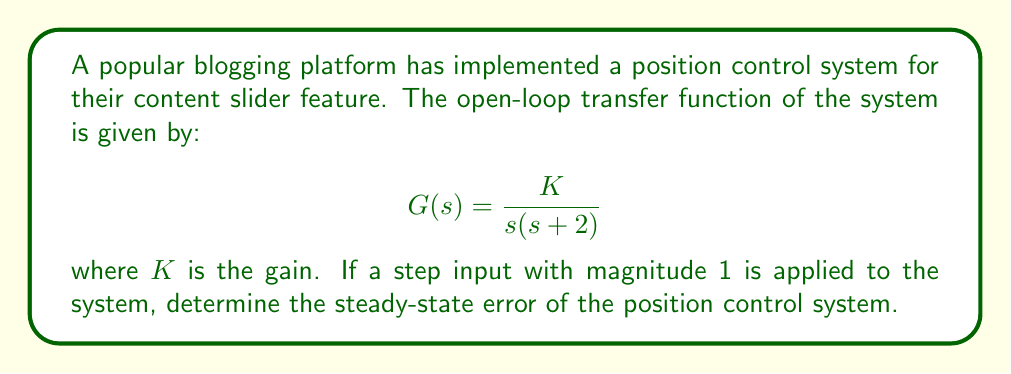Provide a solution to this math problem. To analyze the steady-state error of this position control system, we'll use the final value theorem. Let's approach this step-by-step:

1) First, we need to find the closed-loop transfer function. The closed-loop transfer function is given by:

   $$T(s) = \frac{G(s)}{1 + G(s)} = \frac{K}{s(s+2) + K}$$

2) The error transfer function is:

   $$E(s) = \frac{1}{1 + G(s)} = \frac{s(s+2)}{s(s+2) + K}$$

3) For a step input, $R(s) = \frac{1}{s}$. The error in the s-domain is:

   $$E(s) = \frac{s(s+2)}{s(s+2) + K} \cdot \frac{1}{s} = \frac{s+2}{s(s+2) + K}$$

4) Now, we can apply the final value theorem to find the steady-state error:

   $$e_{ss} = \lim_{s \to 0} sE(s) = \lim_{s \to 0} s \cdot \frac{s+2}{s(s+2) + K}$$

5) Evaluating this limit:

   $$e_{ss} = \lim_{s \to 0} \frac{s(s+2)}{s(s+2) + K} = \frac{0+2}{0+2+K} = \frac{2}{2+K}$$

Therefore, the steady-state error of the position control system is $\frac{2}{2+K}$.
Answer: The steady-state error of the position control system is $\frac{2}{2+K}$. 